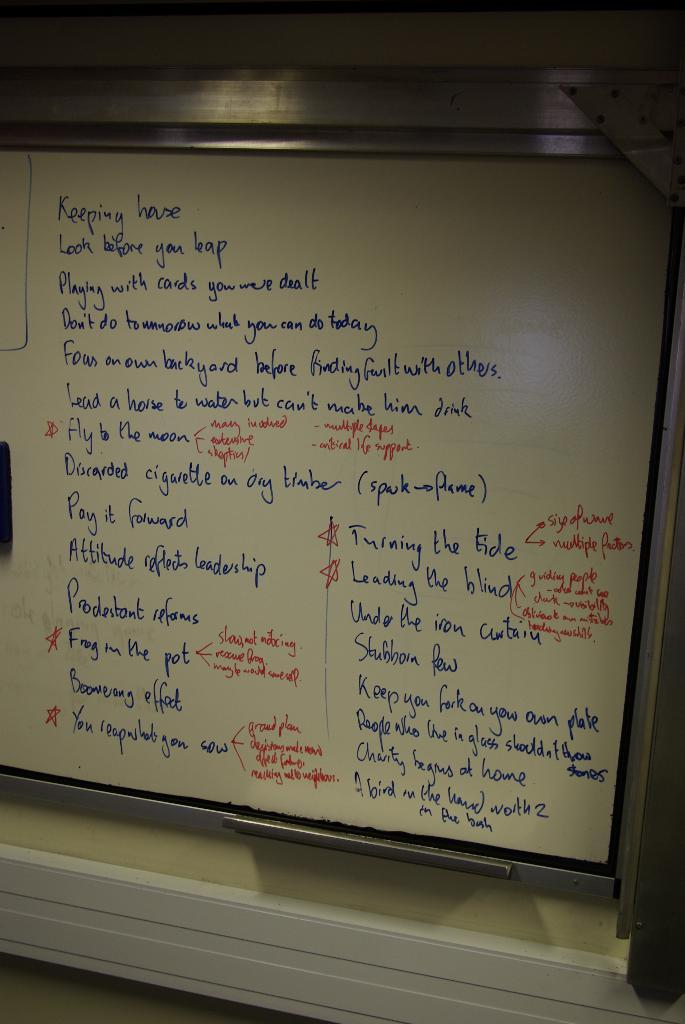<image>
Render a clear and concise summary of the photo. A whiteboard has a long list, starting with the word keeping at the top. 